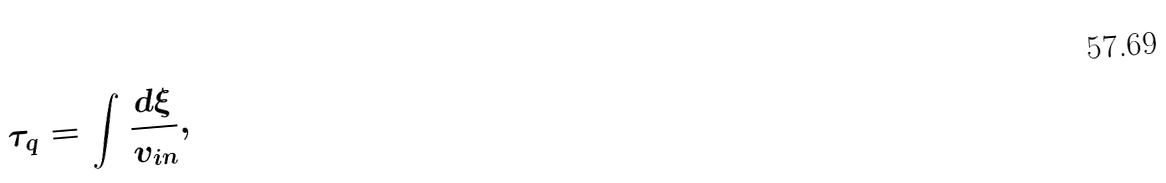<formula> <loc_0><loc_0><loc_500><loc_500>\tau _ { q } = \int \frac { d \xi } { v _ { i n } } ,</formula> 